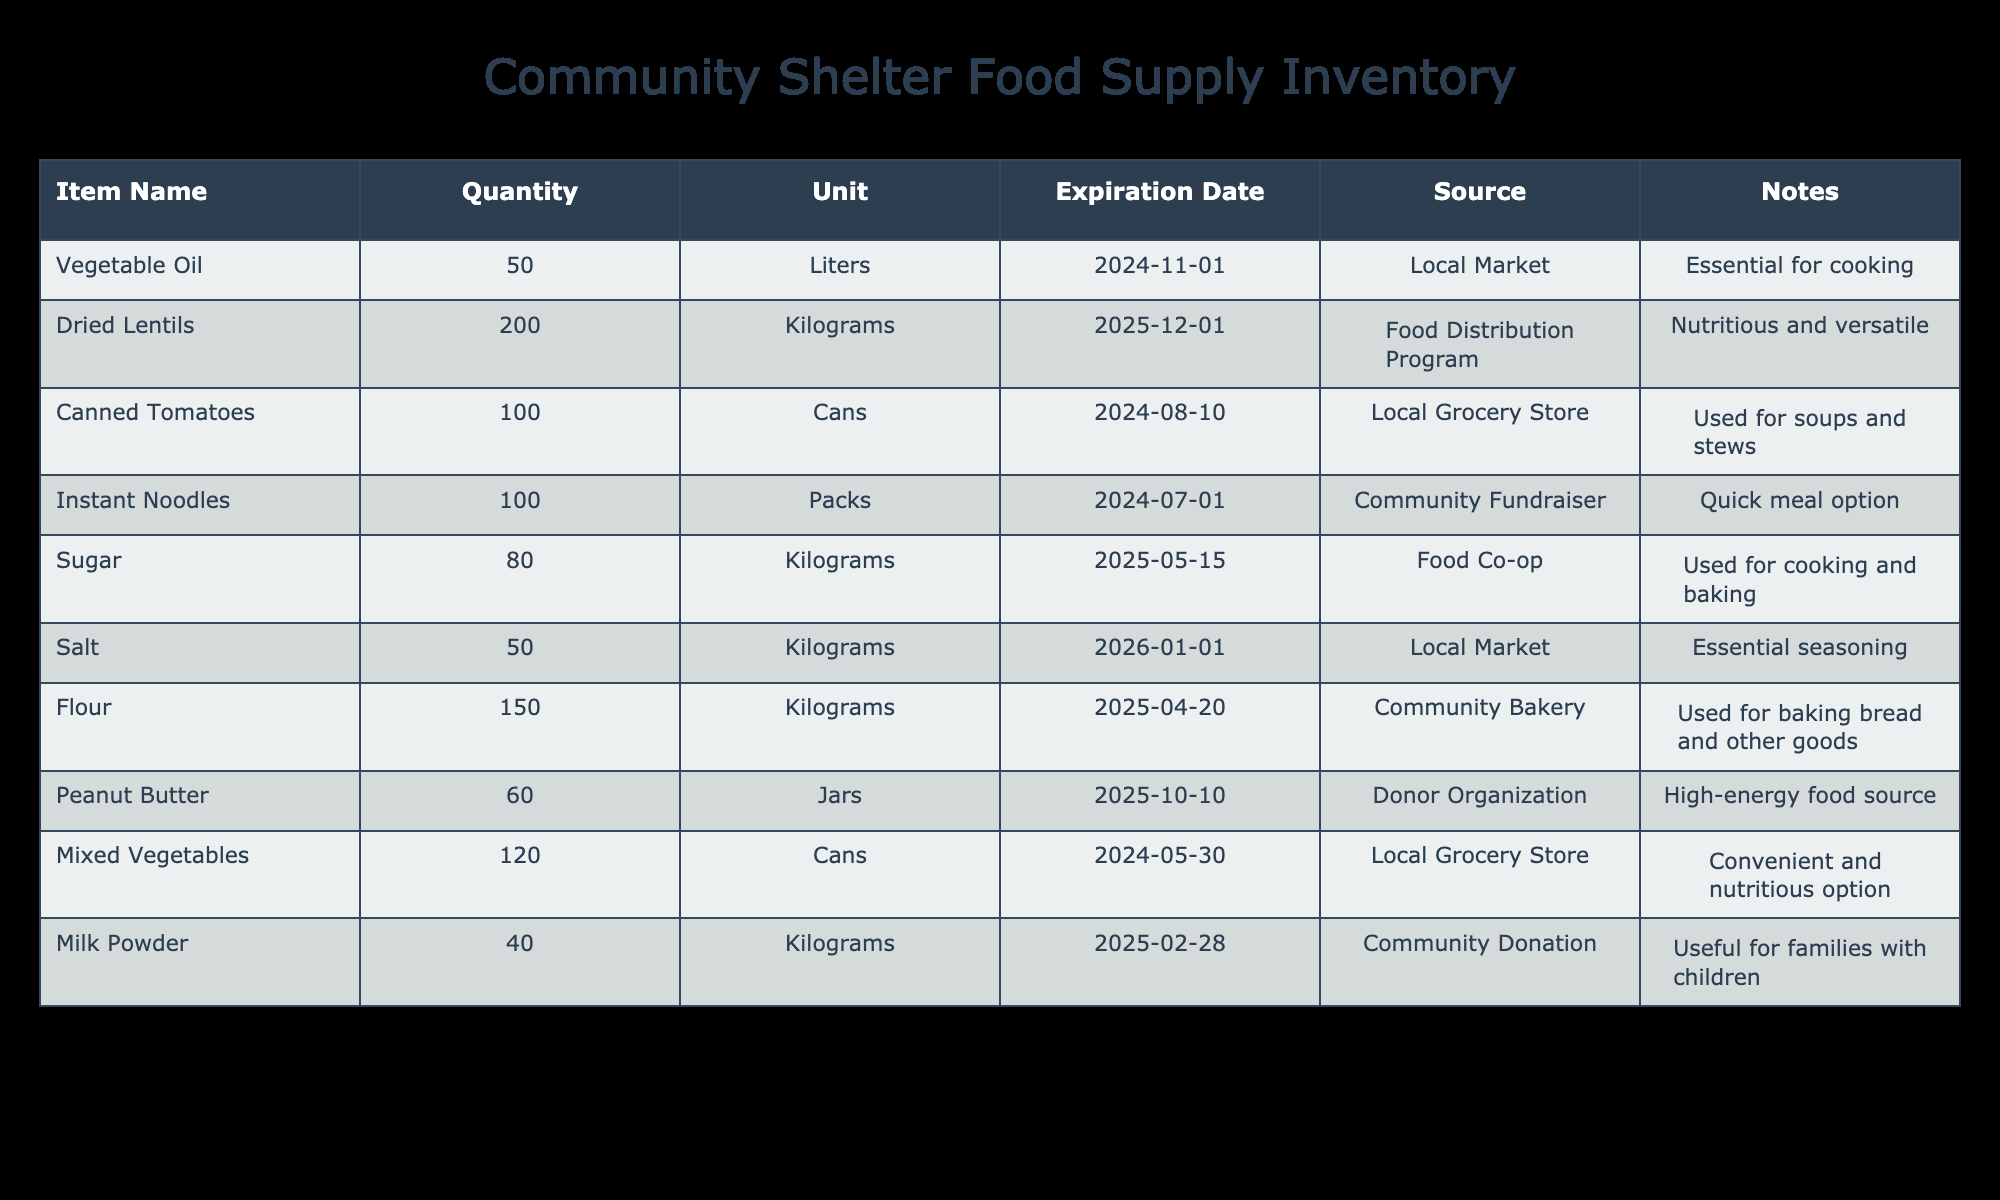What is the total quantity of food items listed in the inventory? To find the total quantity, we add up the quantities of all items: 50 (Vegetable Oil) + 200 (Dried Lentils) + 100 (Canned Tomatoes) + 100 (Instant Noodles) + 80 (Sugar) + 50 (Salt) + 150 (Flour) + 60 (Peanut Butter) + 120 (Mixed Vegetables) + 40 (Milk Powder) = 1,050.
Answer: 1,050 What item has the earliest expiration date, and when does it expire? By scanning through the expiration dates listed for each item, the earliest date is 2024-05-30 for Mixed Vegetables.
Answer: Mixed Vegetables, 2024-05-30 Is there more peanut butter or milk powder available in the inventory? The inventory has 60 jars of Peanut Butter and 40 kilograms of Milk Powder. Since 60 is greater than 40, there is more Peanut Butter.
Answer: Yes, more Peanut Butter What is the total weight in kilograms for all food items that have an expiration date beyond 2025? We look for items expiring after 2025: Salt (50 kg), which is valid for 2026. The total for this item is 50 kg. Other items either expire in 2025 or earlier.
Answer: 50 kg How many different types of canned goods are present in the inventory, and what are they? The inventory lists Canned Tomatoes and Mixed Vegetables as canned goods, totaling 2 different types.
Answer: 2 types: Canned Tomatoes, Mixed Vegetables What is the quantity of food supplies that will expire within the next six months? We check each item’s expiration date against today’s date. The relevant items are Instant Noodles (100 packs, expires 2024-07-01) and Canned Tomatoes (100 cans, expires 2024-08-10). The sum of these quantities is 200.
Answer: 200 Is the total quantity of flour greater than the total quantity of sugar? We compare the quantities: Flour has 150 kg while Sugar has 80 kg. Since 150 is greater than 80, it confirms that the quantity of flour is greater.
Answer: Yes, flour is greater How many cans of vegetables can be produced if we were to use half of the dried lentils? If we use half of the 200 kg of Dried Lentils, we have 100 kg left. However, the conversion rate of lentils to canned goods is not given here, so a specific number cannot be calculated.
Answer: Cannot be determined with given data 